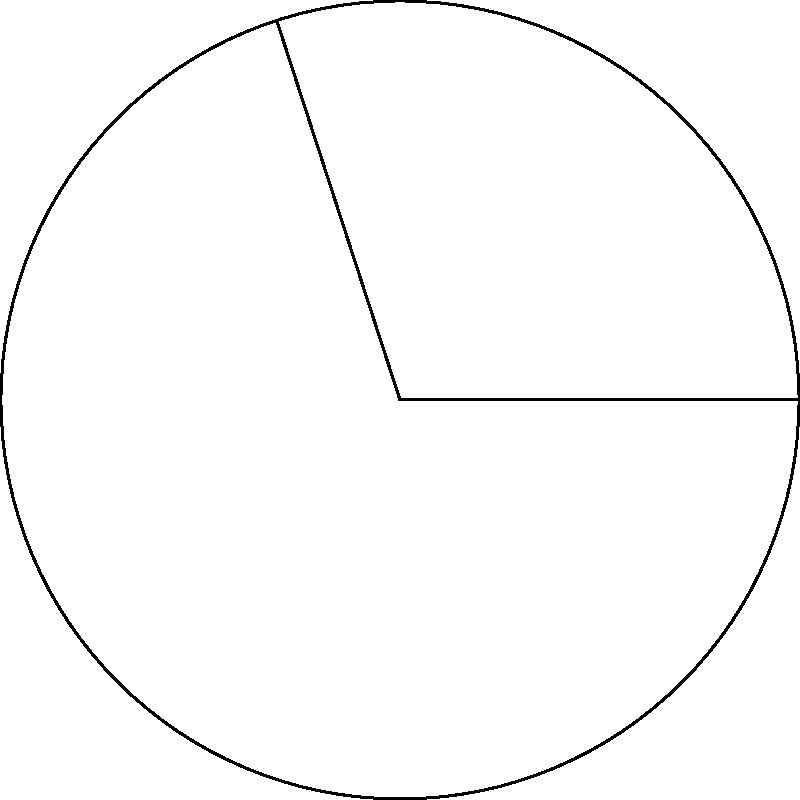In a pie chart visualization for Scala library usage statistics, one sector represents 30% of the total usage. What is the central angle of this sector in degrees? To calculate the central angle of a circular sector in a pie chart:

1. Understand that a full circle has 360°.
2. Set up the proportion:
   $\frac{\text{percentage}}{\text{100\%}} = \frac{\text{central angle}}{360°}$

3. Plug in the given percentage (30%):
   $\frac{30}{100} = \frac{\text{central angle}}{360°}$

4. Cross multiply:
   $30 \times 360° = 100 \times \text{central angle}$

5. Solve for the central angle:
   $10,800° = 100 \times \text{central angle}$
   $\text{central angle} = \frac{10,800°}{100} = 108°$

Therefore, the central angle of the sector representing 30% of the total usage is 108°.
Answer: 108° 